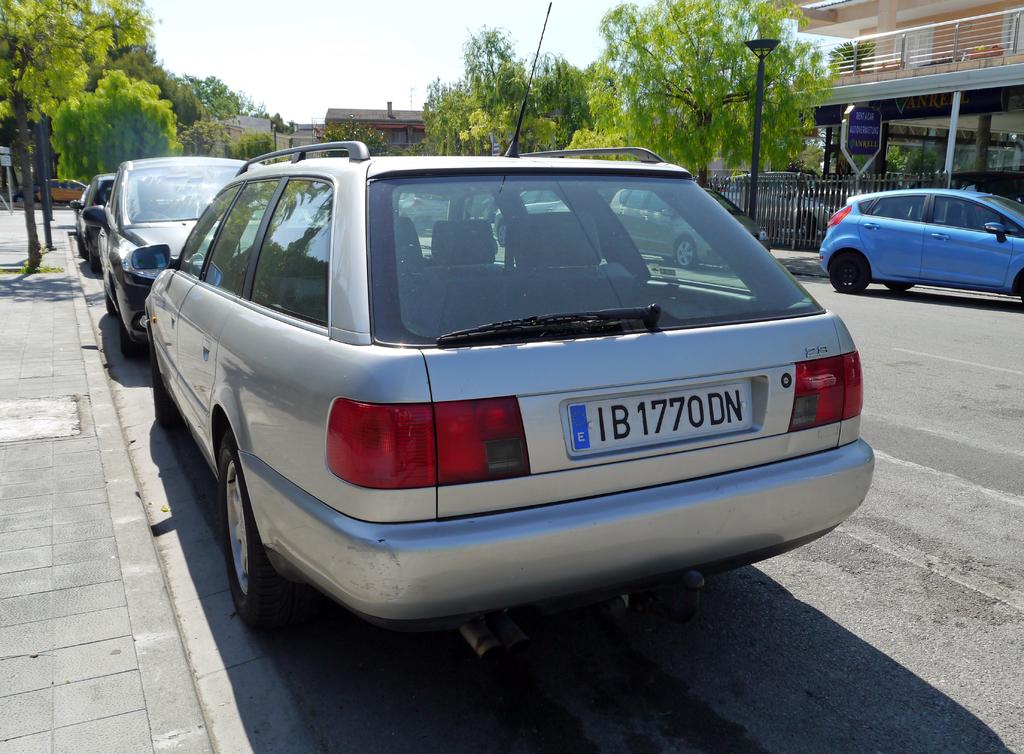What is the letter in the blue area on the plate?
Ensure brevity in your answer.  E. What is the plate number?
Keep it short and to the point. Ib1770dn. 